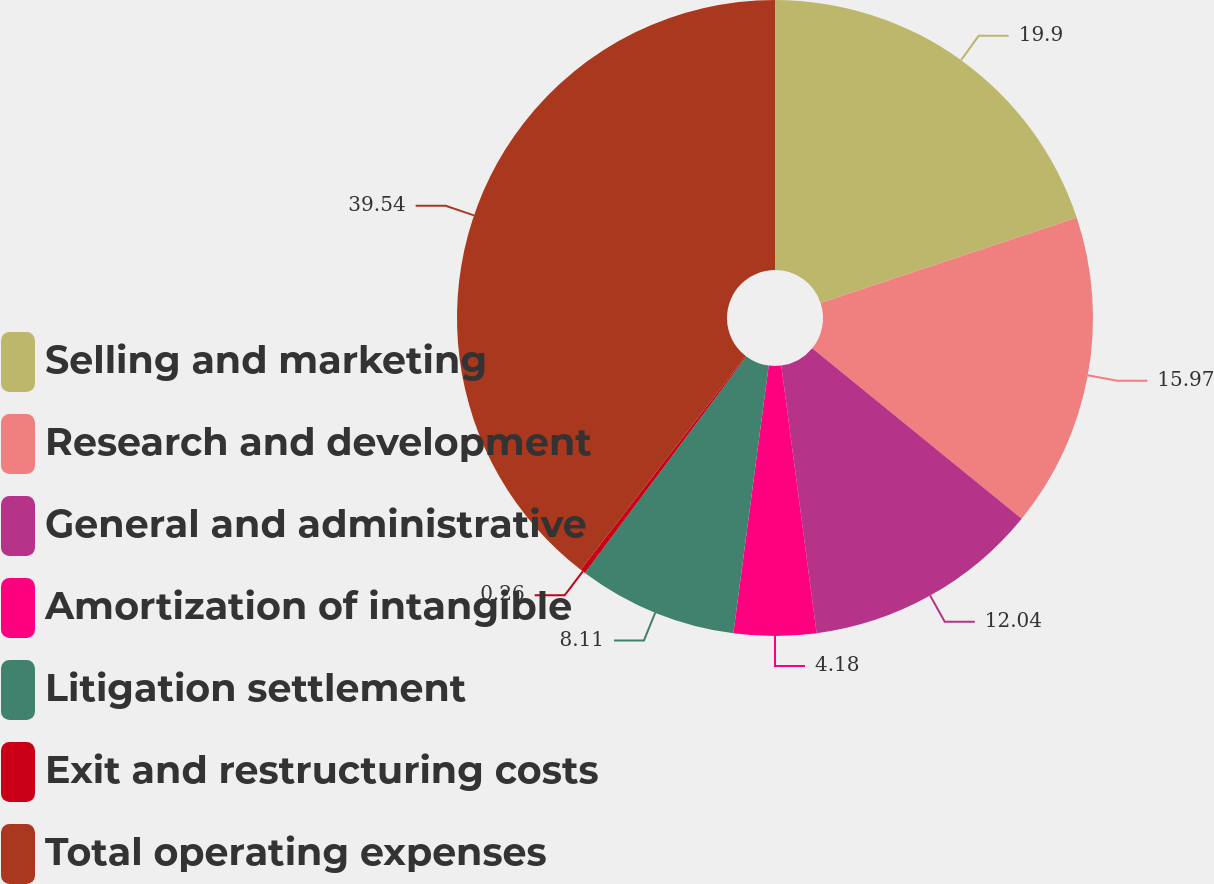Convert chart to OTSL. <chart><loc_0><loc_0><loc_500><loc_500><pie_chart><fcel>Selling and marketing<fcel>Research and development<fcel>General and administrative<fcel>Amortization of intangible<fcel>Litigation settlement<fcel>Exit and restructuring costs<fcel>Total operating expenses<nl><fcel>19.9%<fcel>15.97%<fcel>12.04%<fcel>4.18%<fcel>8.11%<fcel>0.26%<fcel>39.54%<nl></chart> 